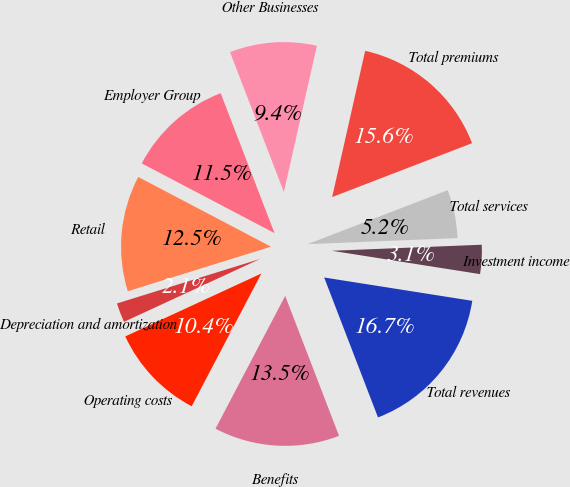Convert chart. <chart><loc_0><loc_0><loc_500><loc_500><pie_chart><fcel>Retail<fcel>Employer Group<fcel>Other Businesses<fcel>Total premiums<fcel>Total services<fcel>Investment income<fcel>Total revenues<fcel>Benefits<fcel>Operating costs<fcel>Depreciation and amortization<nl><fcel>12.5%<fcel>11.46%<fcel>9.38%<fcel>15.62%<fcel>5.21%<fcel>3.13%<fcel>16.67%<fcel>13.54%<fcel>10.42%<fcel>2.09%<nl></chart> 